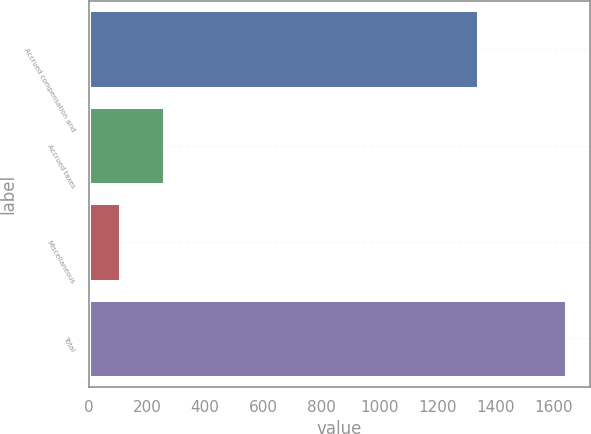Convert chart to OTSL. <chart><loc_0><loc_0><loc_500><loc_500><bar_chart><fcel>Accrued compensation and<fcel>Accrued taxes<fcel>Miscellaneous<fcel>Total<nl><fcel>1341.9<fcel>259.45<fcel>105.7<fcel>1643.2<nl></chart> 